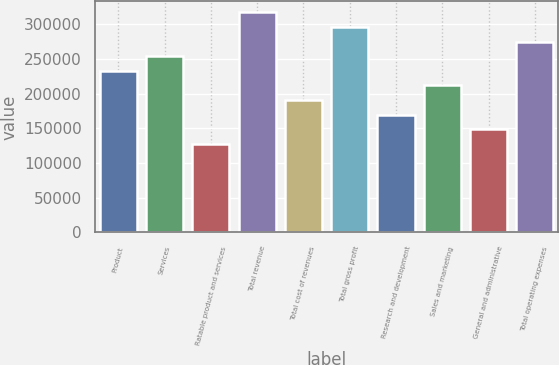<chart> <loc_0><loc_0><loc_500><loc_500><bar_chart><fcel>Product<fcel>Services<fcel>Ratable product and services<fcel>Total revenue<fcel>Total cost of revenues<fcel>Total gross profit<fcel>Research and development<fcel>Sales and marketing<fcel>General and administrative<fcel>Total operating expenses<nl><fcel>232799<fcel>253807<fcel>127759<fcel>316832<fcel>190783<fcel>295823<fcel>169775<fcel>211791<fcel>148767<fcel>274815<nl></chart> 